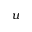<formula> <loc_0><loc_0><loc_500><loc_500>u</formula> 